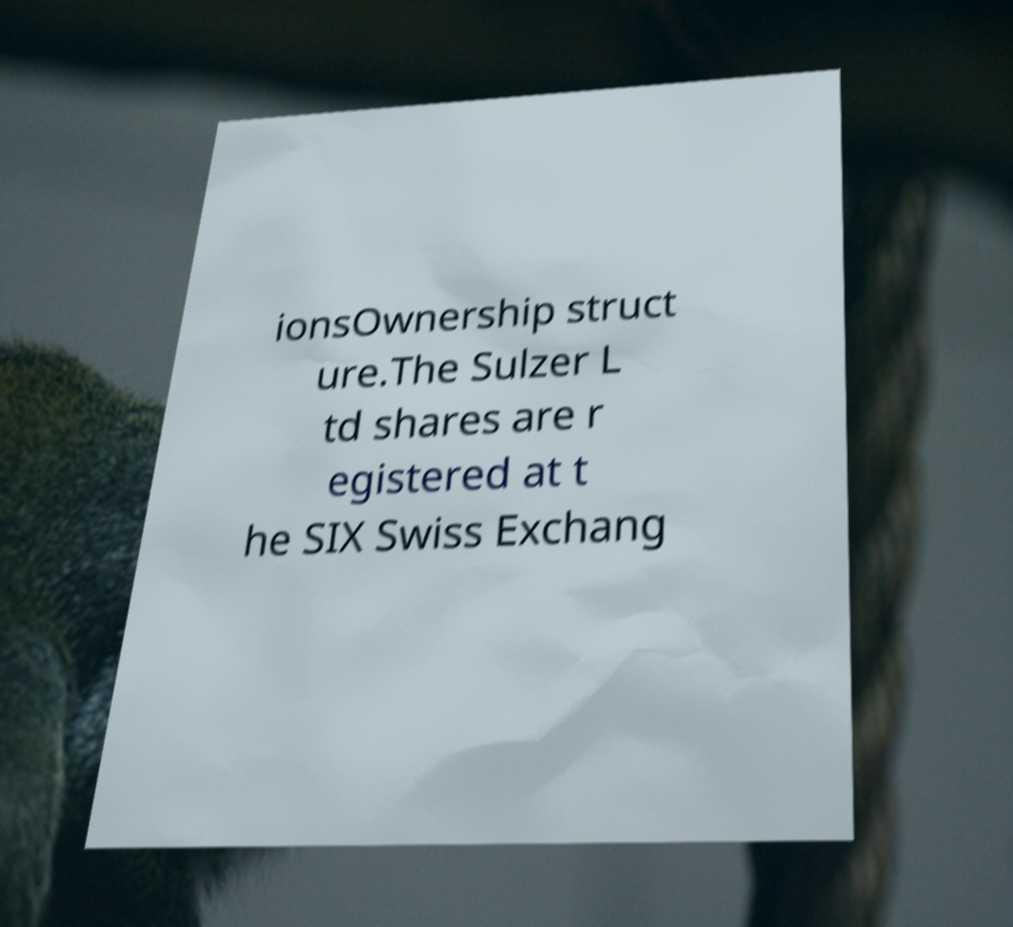What messages or text are displayed in this image? I need them in a readable, typed format. ionsOwnership struct ure.The Sulzer L td shares are r egistered at t he SIX Swiss Exchang 